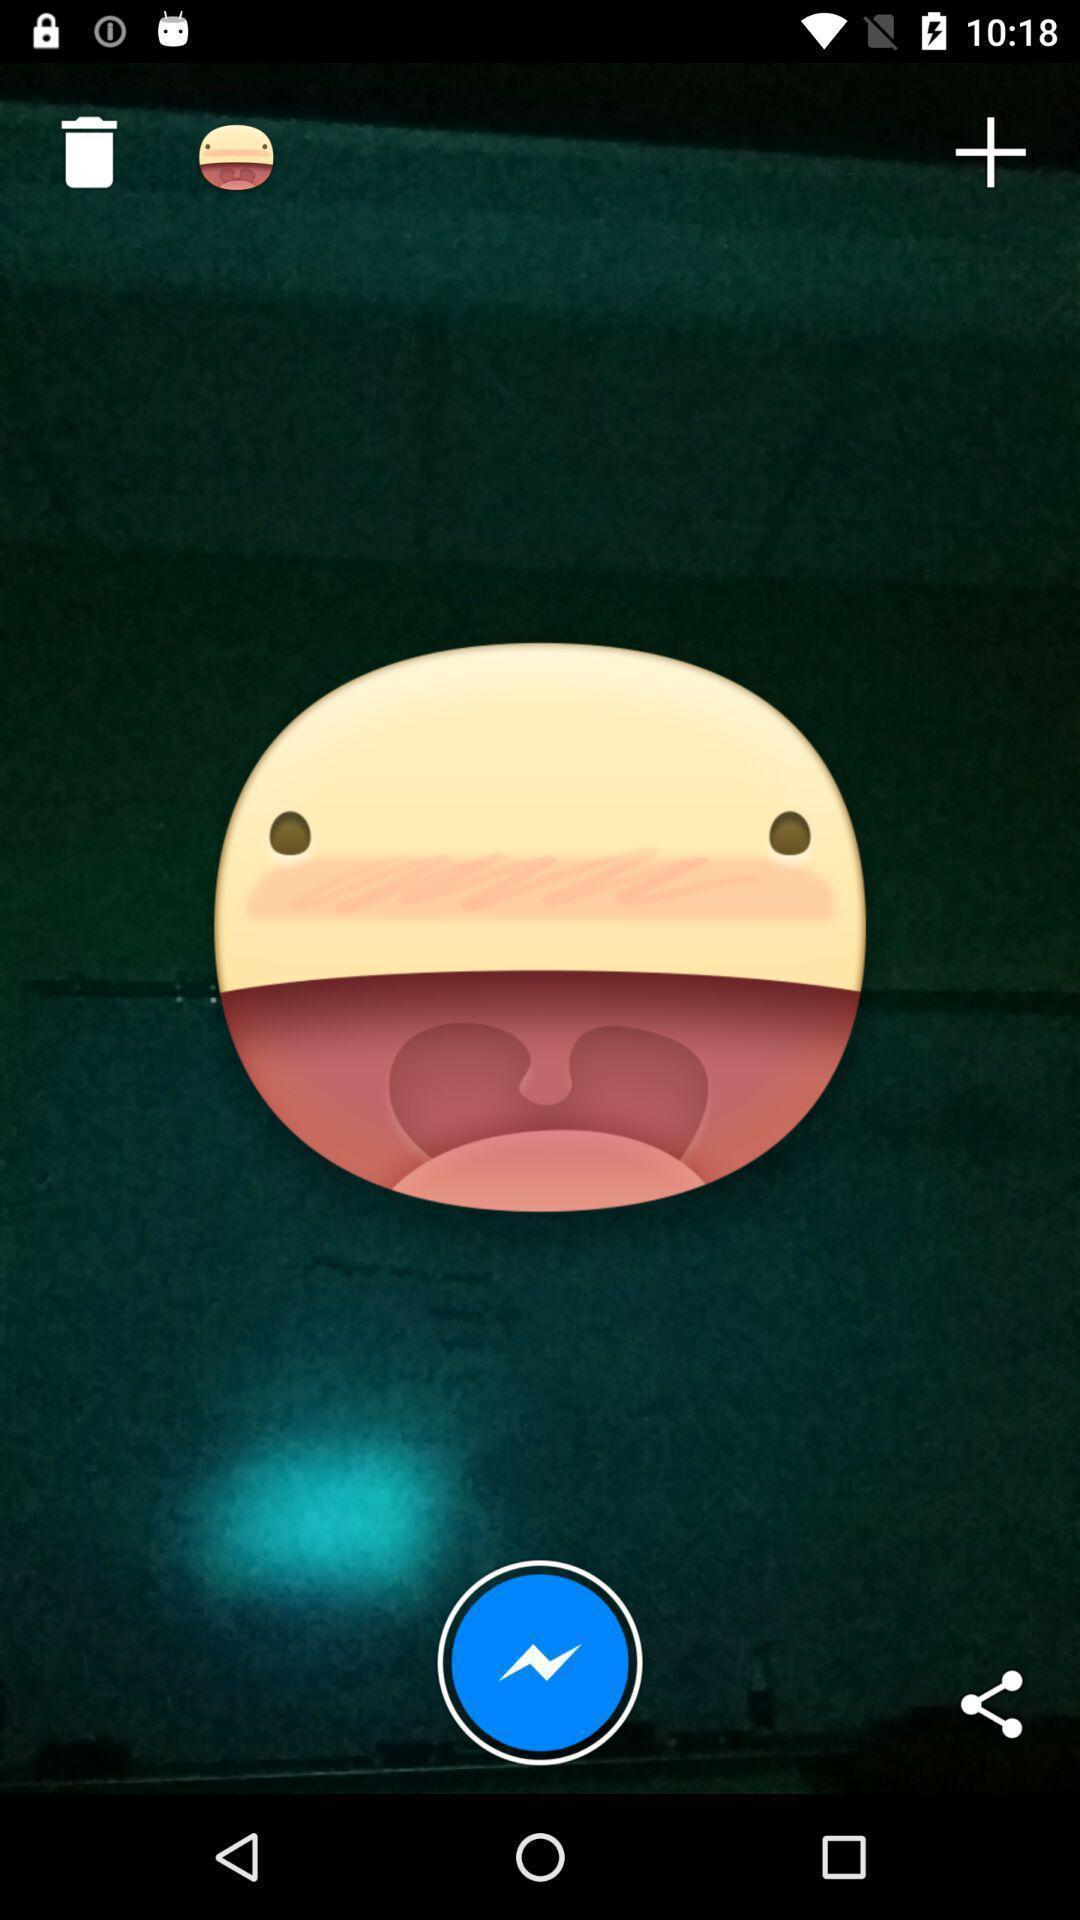Describe the visual elements of this screenshot. Page showing the emoji in social app. 